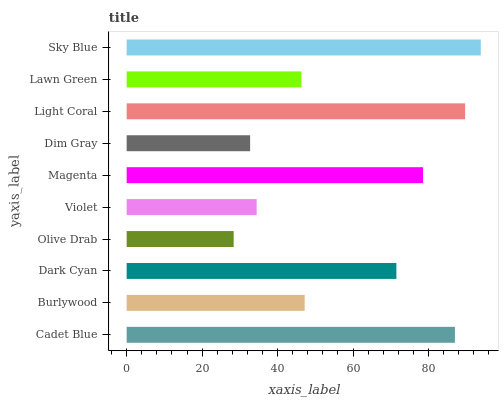Is Olive Drab the minimum?
Answer yes or no. Yes. Is Sky Blue the maximum?
Answer yes or no. Yes. Is Burlywood the minimum?
Answer yes or no. No. Is Burlywood the maximum?
Answer yes or no. No. Is Cadet Blue greater than Burlywood?
Answer yes or no. Yes. Is Burlywood less than Cadet Blue?
Answer yes or no. Yes. Is Burlywood greater than Cadet Blue?
Answer yes or no. No. Is Cadet Blue less than Burlywood?
Answer yes or no. No. Is Dark Cyan the high median?
Answer yes or no. Yes. Is Burlywood the low median?
Answer yes or no. Yes. Is Violet the high median?
Answer yes or no. No. Is Dim Gray the low median?
Answer yes or no. No. 